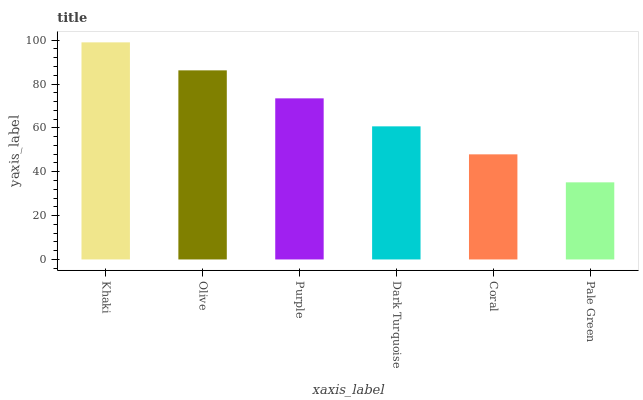Is Olive the minimum?
Answer yes or no. No. Is Olive the maximum?
Answer yes or no. No. Is Khaki greater than Olive?
Answer yes or no. Yes. Is Olive less than Khaki?
Answer yes or no. Yes. Is Olive greater than Khaki?
Answer yes or no. No. Is Khaki less than Olive?
Answer yes or no. No. Is Purple the high median?
Answer yes or no. Yes. Is Dark Turquoise the low median?
Answer yes or no. Yes. Is Khaki the high median?
Answer yes or no. No. Is Coral the low median?
Answer yes or no. No. 